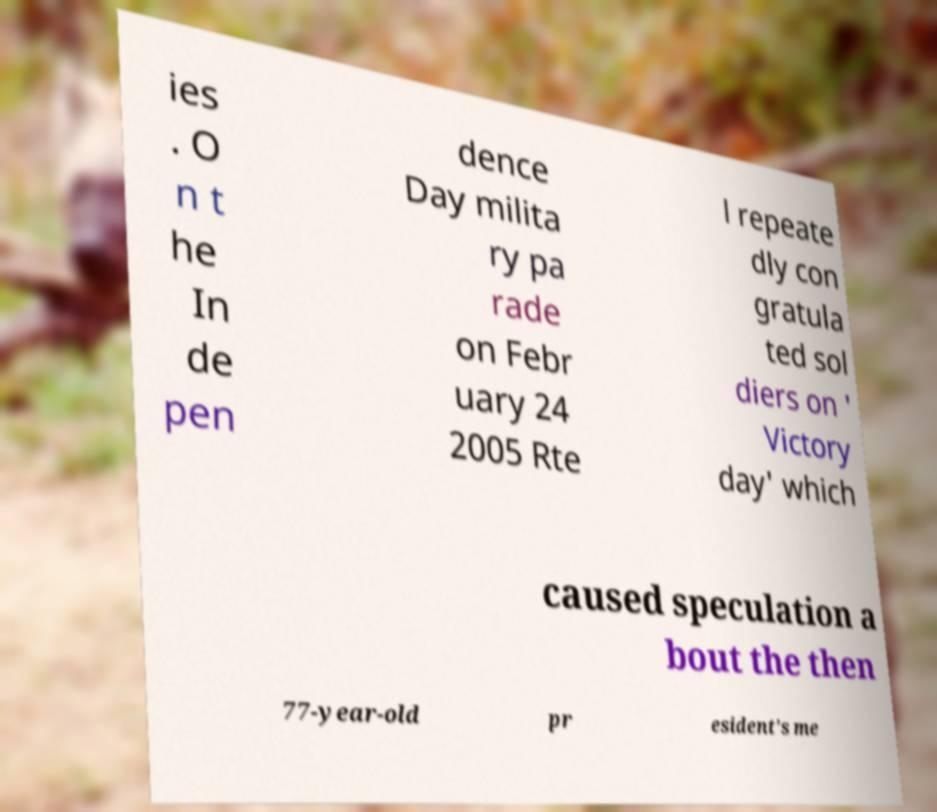I need the written content from this picture converted into text. Can you do that? ies . O n t he In de pen dence Day milita ry pa rade on Febr uary 24 2005 Rte l repeate dly con gratula ted sol diers on ' Victory day' which caused speculation a bout the then 77-year-old pr esident's me 